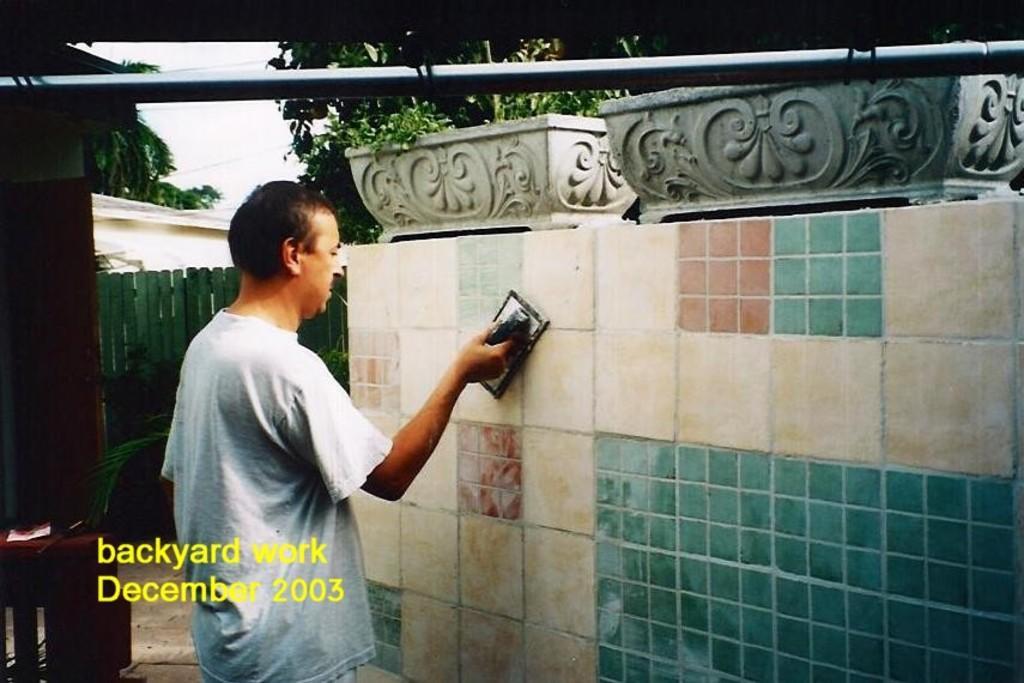Describe this image in one or two sentences. In this picture I can see there is a man, holding a brush and there is a wall in front of him, there are few flower pots with plants and there is a green color gate in the backdrop and there are few trees and the sky is clear. 